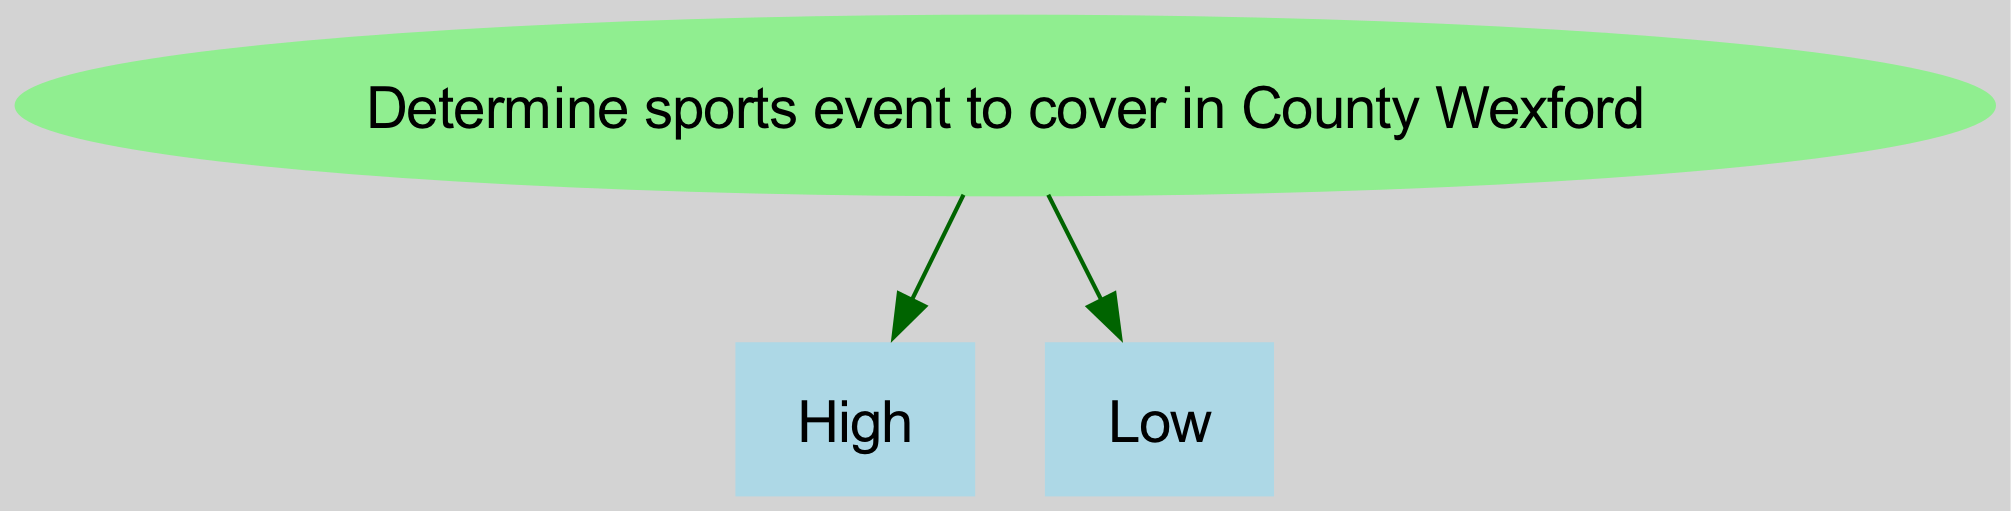What is the root of the diagram? The root of the diagram is "Determine sports event to cover in County Wexford". It is the topmost node that describes the main objective of the decision tree.
Answer: Determine sports event to cover in County Wexford How many main branches are there from the root node? From the root node, there are two main branches: "Local interest level" and "Potential media impact." Therefore, the count of branches is two.
Answer: 2 What happens if local interest is high and the venue is unavailable? If local interest is high, the next evaluation would be on venue availability. If the venue is unavailable, it leads to "Alternative venue," where it checks if an alternative venue is found or not.
Answer: Alternative venue If the media impact is low, what is the next step? If the potential media impact is low, the next step is to "Reconsider event options." This indicates that the event is not seen as worthwhile for coverage.
Answer: Reconsider event options Which event types are possible if the venue is available? If the venue is available, the possible event types listed are "GAA match," "Soccer match," and "Horse racing." These are the events that can be covered given the venue situation.
Answer: GAA match, Soccer match, Horse racing What is the outcome if an alternative venue is not found? If an alternative venue is not found, the next outcome is also to "Reconsider event options". This indicates that without a venue, there may not be suitable options available for covering an event.
Answer: Reconsider event options What does a high local interest lead to after checking venue availability? High local interest first directs to a check on "Venue availability." If the venue is available, it then leads to determining the "Event type," hence leading to specific sports events.
Answer: Event type How does the tree handle low local interest? If the local interest level is low, it leads directly to checking the "Potential media impact." This indicates that low interest triggers an evaluation of how impactful the event coverage might be.
Answer: Potential media impact 